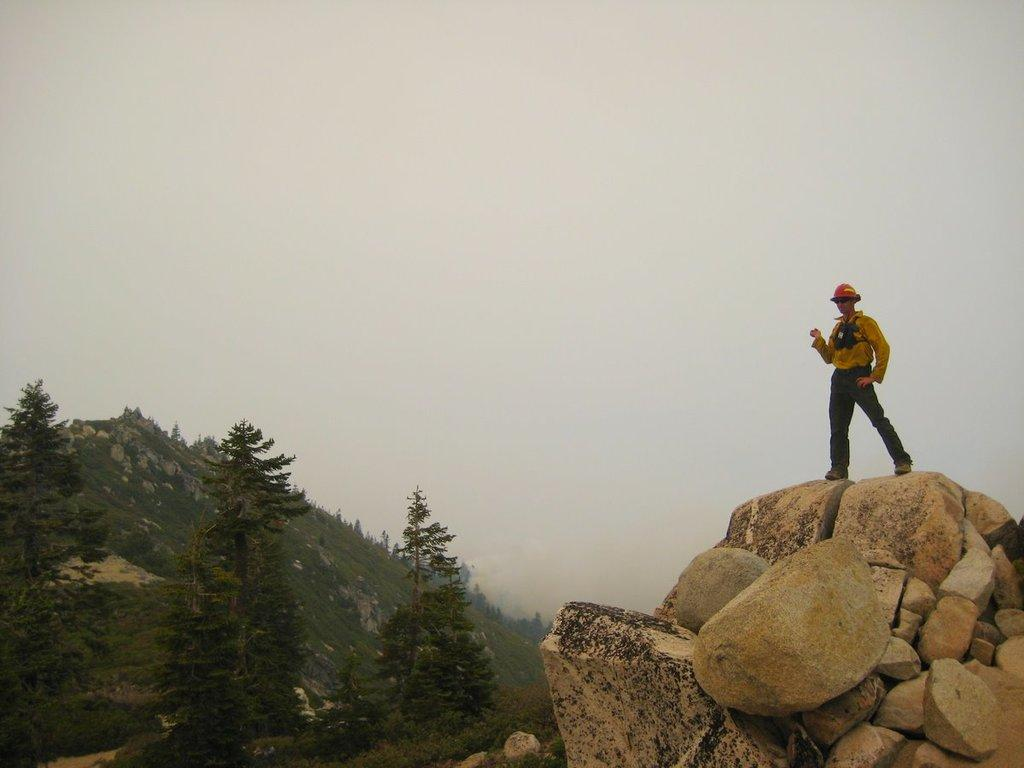What is the person in the image standing on? The person is standing on rocks in the image. What can be seen in the background of the image? There are trees and a mountain in the background of the image. What is visible in the sky in the image? The sky is visible in the background of the image. What arithmetic problem is the person solving on the rocks in the image? There is no arithmetic problem visible in the image; the person is simply standing on rocks. Can you describe the person's facial expression in the image? The provided facts do not mention the person's facial expression, so it cannot be determined from the image. 